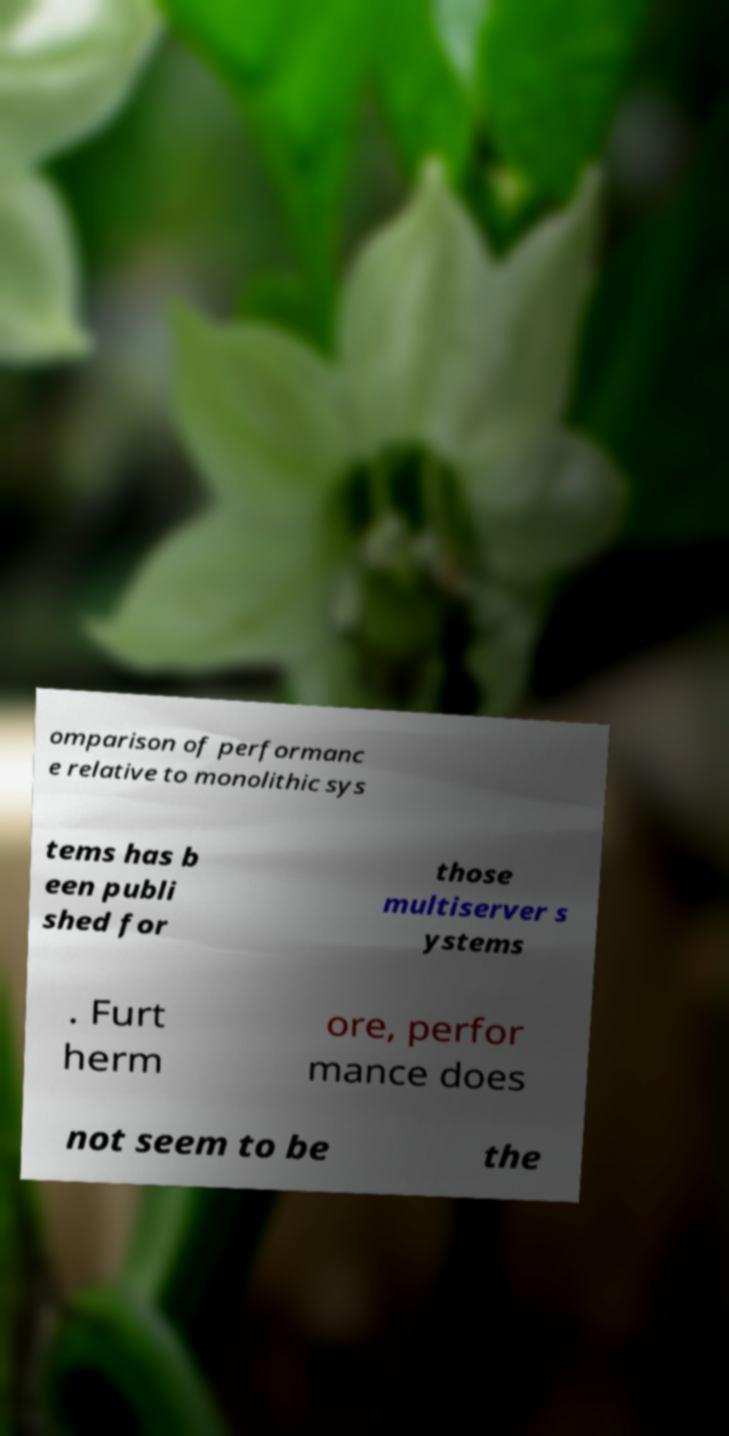Please identify and transcribe the text found in this image. omparison of performanc e relative to monolithic sys tems has b een publi shed for those multiserver s ystems . Furt herm ore, perfor mance does not seem to be the 